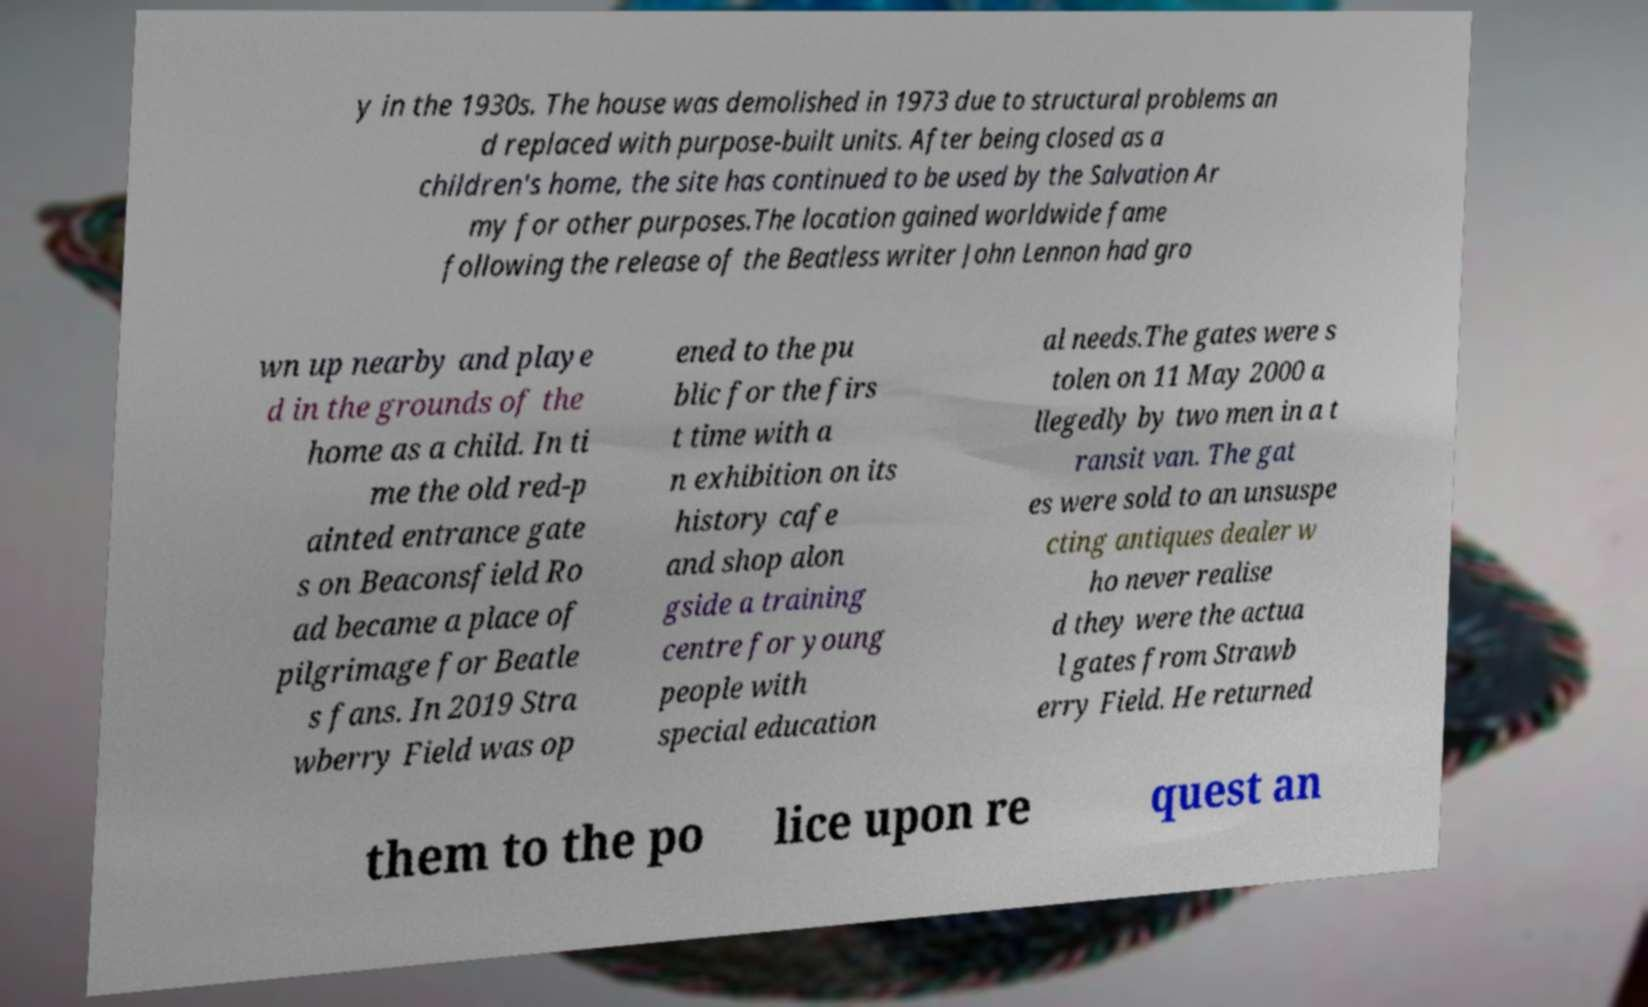For documentation purposes, I need the text within this image transcribed. Could you provide that? y in the 1930s. The house was demolished in 1973 due to structural problems an d replaced with purpose-built units. After being closed as a children's home, the site has continued to be used by the Salvation Ar my for other purposes.The location gained worldwide fame following the release of the Beatless writer John Lennon had gro wn up nearby and playe d in the grounds of the home as a child. In ti me the old red-p ainted entrance gate s on Beaconsfield Ro ad became a place of pilgrimage for Beatle s fans. In 2019 Stra wberry Field was op ened to the pu blic for the firs t time with a n exhibition on its history cafe and shop alon gside a training centre for young people with special education al needs.The gates were s tolen on 11 May 2000 a llegedly by two men in a t ransit van. The gat es were sold to an unsuspe cting antiques dealer w ho never realise d they were the actua l gates from Strawb erry Field. He returned them to the po lice upon re quest an 